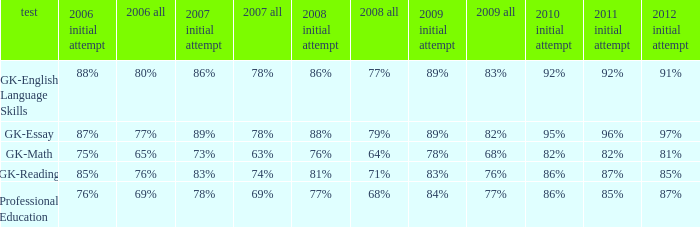What is the percentage for first time 2011 when the first time in 2009 is 68%? 82%. 